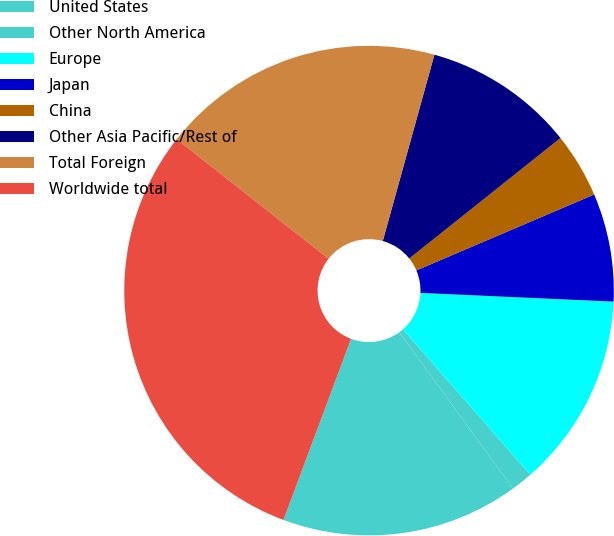Convert chart. <chart><loc_0><loc_0><loc_500><loc_500><pie_chart><fcel>United States<fcel>Other North America<fcel>Europe<fcel>Japan<fcel>China<fcel>Other Asia Pacific/Rest of<fcel>Total Foreign<fcel>Worldwide total<nl><fcel>15.69%<fcel>1.44%<fcel>12.84%<fcel>7.14%<fcel>4.29%<fcel>9.99%<fcel>18.69%<fcel>29.94%<nl></chart> 